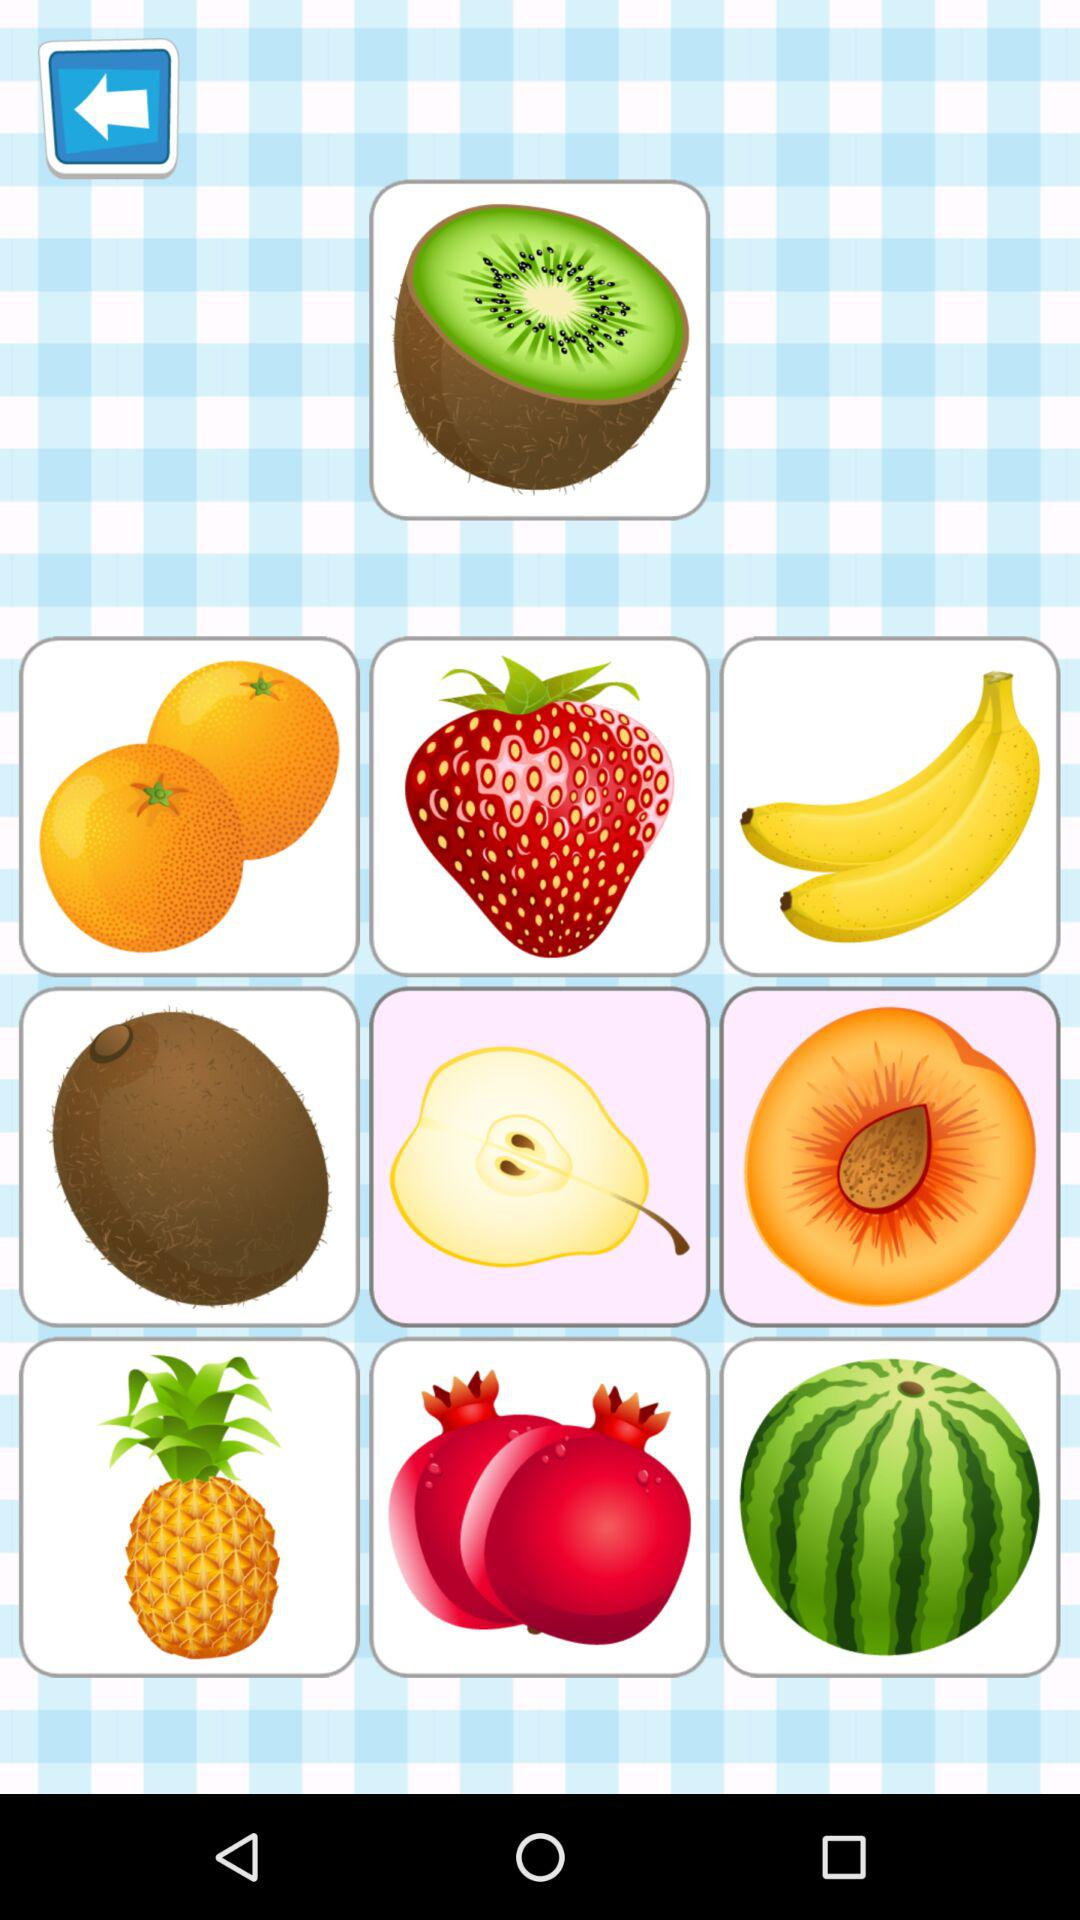How many more items are in the second row than the first row?
Answer the question using a single word or phrase. 2 